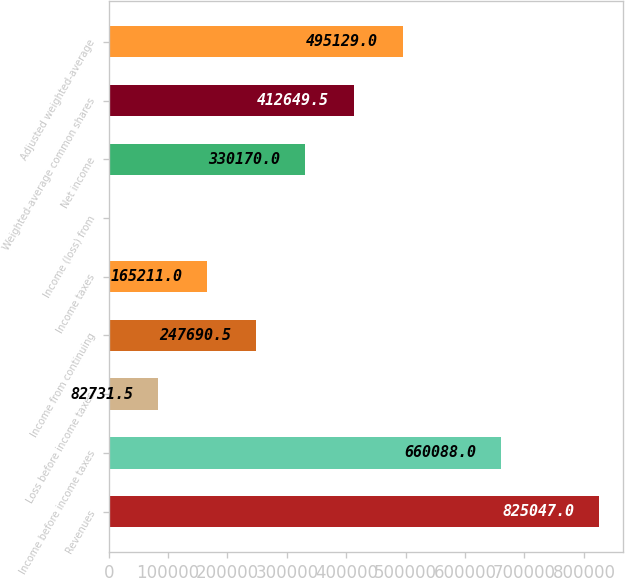<chart> <loc_0><loc_0><loc_500><loc_500><bar_chart><fcel>Revenues<fcel>Income before income taxes<fcel>Loss before income taxes<fcel>Income from continuing<fcel>Income taxes<fcel>Income (loss) from<fcel>Net income<fcel>Weighted-average common shares<fcel>Adjusted weighted-average<nl><fcel>825047<fcel>660088<fcel>82731.5<fcel>247690<fcel>165211<fcel>252<fcel>330170<fcel>412650<fcel>495129<nl></chart> 